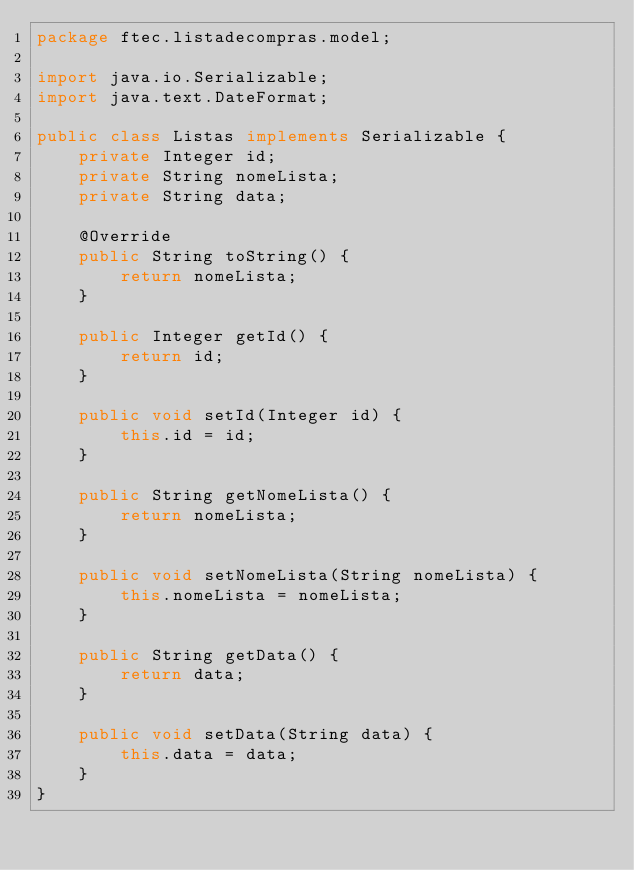<code> <loc_0><loc_0><loc_500><loc_500><_Java_>package ftec.listadecompras.model;

import java.io.Serializable;
import java.text.DateFormat;

public class Listas implements Serializable {
    private Integer id;
    private String nomeLista;
    private String data;

    @Override
    public String toString() {
        return nomeLista;
    }

    public Integer getId() {
        return id;
    }

    public void setId(Integer id) {
        this.id = id;
    }

    public String getNomeLista() {
        return nomeLista;
    }

    public void setNomeLista(String nomeLista) {
        this.nomeLista = nomeLista;
    }

    public String getData() {
        return data;
    }

    public void setData(String data) {
        this.data = data;
    }
}
</code> 